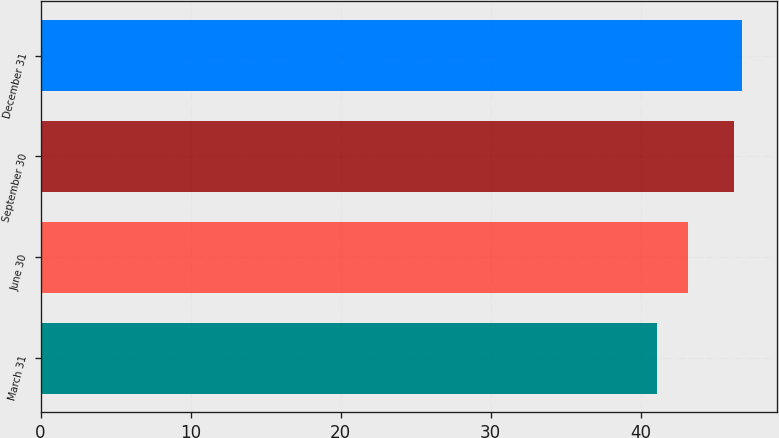Convert chart to OTSL. <chart><loc_0><loc_0><loc_500><loc_500><bar_chart><fcel>March 31<fcel>June 30<fcel>September 30<fcel>December 31<nl><fcel>41.1<fcel>43.15<fcel>46.25<fcel>46.77<nl></chart> 